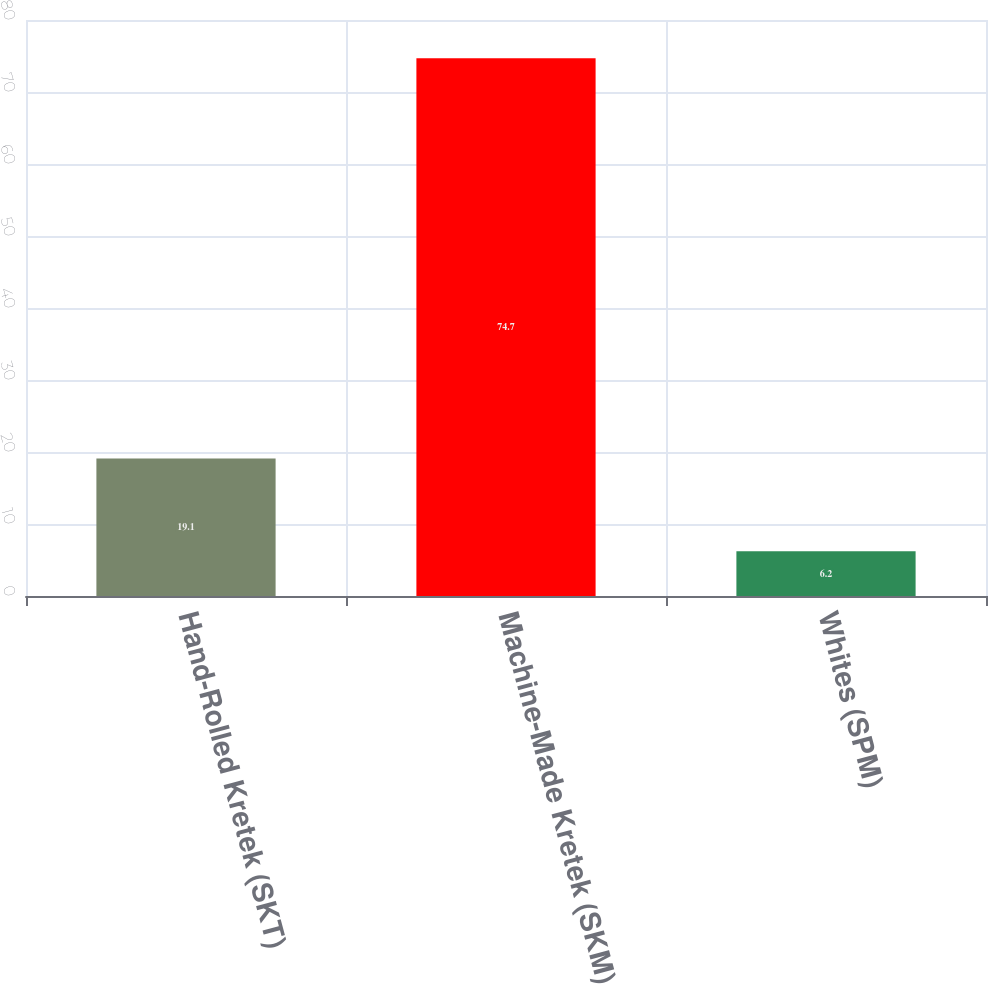<chart> <loc_0><loc_0><loc_500><loc_500><bar_chart><fcel>Hand-Rolled Kretek (SKT)<fcel>Machine-Made Kretek (SKM)<fcel>Whites (SPM)<nl><fcel>19.1<fcel>74.7<fcel>6.2<nl></chart> 